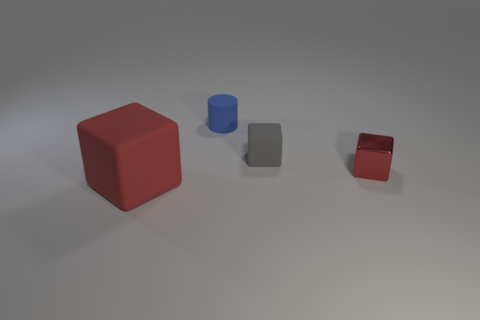Is there anything else that has the same size as the red rubber block?
Provide a succinct answer. No. The blue matte object to the right of the rubber thing that is in front of the small red shiny block is what shape?
Provide a succinct answer. Cylinder. There is a gray matte object; does it have the same shape as the red object behind the big rubber thing?
Keep it short and to the point. Yes. There is a thing that is right of the gray object; what number of red blocks are to the right of it?
Offer a terse response. 0. What is the material of the other tiny object that is the same shape as the tiny gray thing?
Provide a short and direct response. Metal. How many cyan objects are either rubber cylinders or tiny blocks?
Your answer should be very brief. 0. Is there anything else that is the same color as the tiny metal thing?
Your answer should be compact. Yes. There is a rubber block that is on the right side of the rubber cube that is in front of the shiny block; what is its color?
Offer a very short reply. Gray. Is the number of blocks that are on the left side of the shiny block less than the number of blue cylinders that are in front of the small blue matte cylinder?
Your answer should be compact. No. What material is the tiny object that is the same color as the large matte block?
Keep it short and to the point. Metal. 